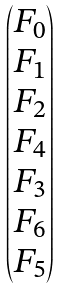<formula> <loc_0><loc_0><loc_500><loc_500>\begin{pmatrix} F _ { 0 } \\ F _ { 1 } \\ F _ { 2 } \\ F _ { 4 } \\ F _ { 3 } \\ F _ { 6 } \\ F _ { 5 } \\ \end{pmatrix}</formula> 